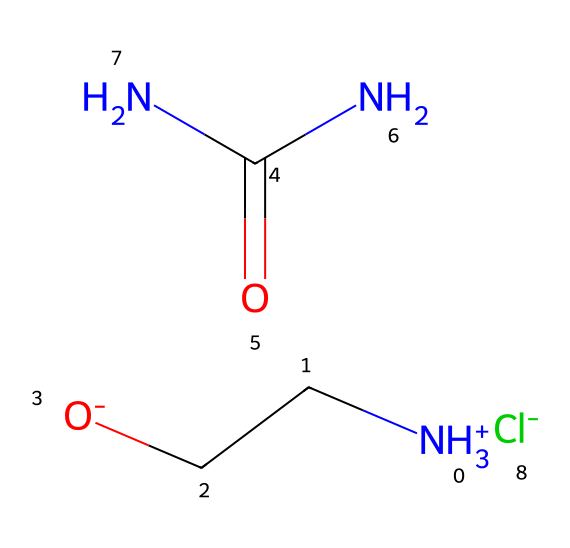What type of ions are present in this compound? This compound contains a positively charged ammonium ion (choline) and a negatively charged chloride ion, which are characteristic of ionic liquids.
Answer: ammonium and chloride How many nitrogen atoms are in the structure? By analyzing the SMILES representation, we can see there are two nitrogen atoms: one in the ammonium ion and another in the urea portion.
Answer: two What is the overall charge of the ionic liquid? The ammonium ion has a positive charge, and the chloride ion has a negative charge, resulting in a neutral overall charge for the ionic liquid.
Answer: neutral What functional groups are present in this compound? The compound contains an ammonium group (due to the presence of -NH3+) and a urea functional group (-C(=O)(N)N), characteristic of deep eutectic solvents.
Answer: ammonium and urea How many carbon atoms are in the structure? Analyzing the SMILES representation reveals there are three carbon atoms: one in the choline part and two in the urea group.
Answer: three What type of solvent is formed from choline chloride and urea? Choline chloride and urea combine to form a deep eutectic solvent, which has unique properties beneficial for various applications.
Answer: deep eutectic solvent 